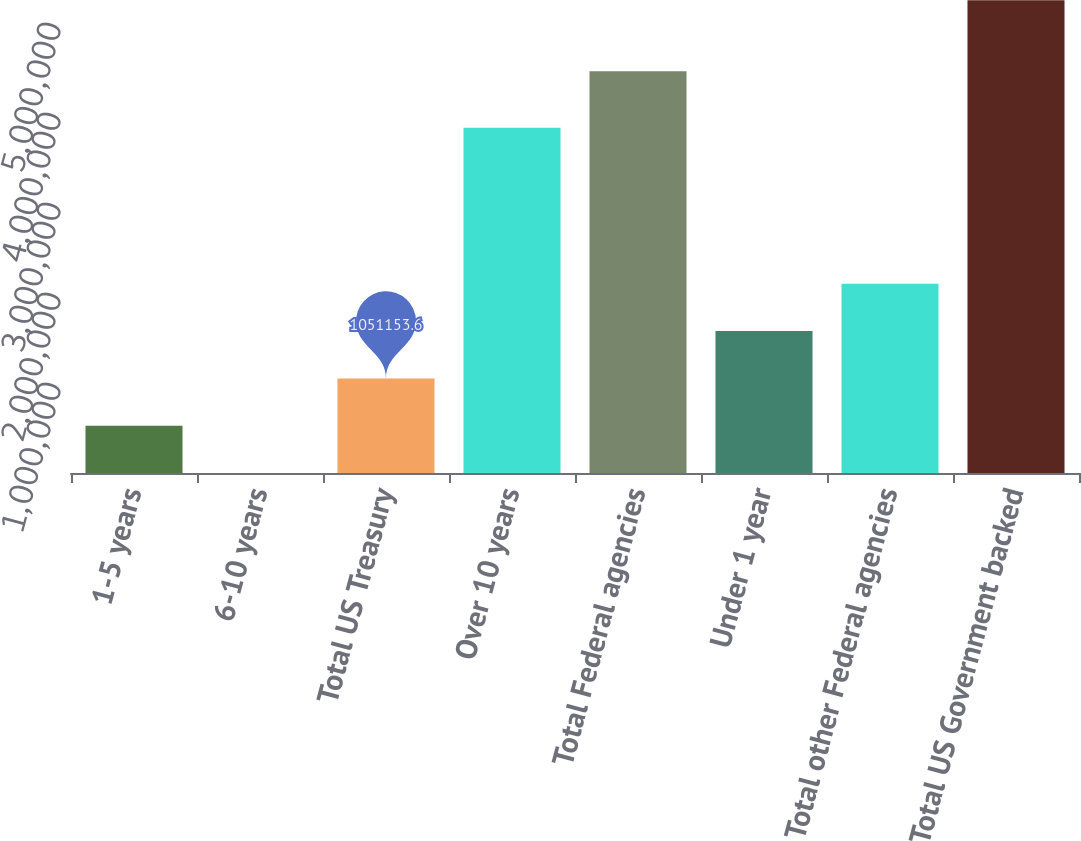Convert chart to OTSL. <chart><loc_0><loc_0><loc_500><loc_500><bar_chart><fcel>1-5 years<fcel>6-10 years<fcel>Total US Treasury<fcel>Over 10 years<fcel>Total Federal agencies<fcel>Under 1 year<fcel>Total other Federal agencies<fcel>Total US Government backed<nl><fcel>525843<fcel>532<fcel>1.05115e+06<fcel>3.83632e+06<fcel>4.46489e+06<fcel>1.57646e+06<fcel>2.10178e+06<fcel>5.25364e+06<nl></chart> 